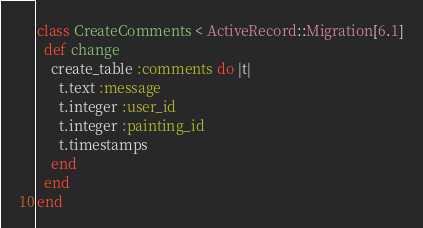<code> <loc_0><loc_0><loc_500><loc_500><_Ruby_>class CreateComments < ActiveRecord::Migration[6.1]
  def change
    create_table :comments do |t|
      t.text :message
      t.integer :user_id
      t.integer :painting_id
      t.timestamps
    end
  end
end
</code> 